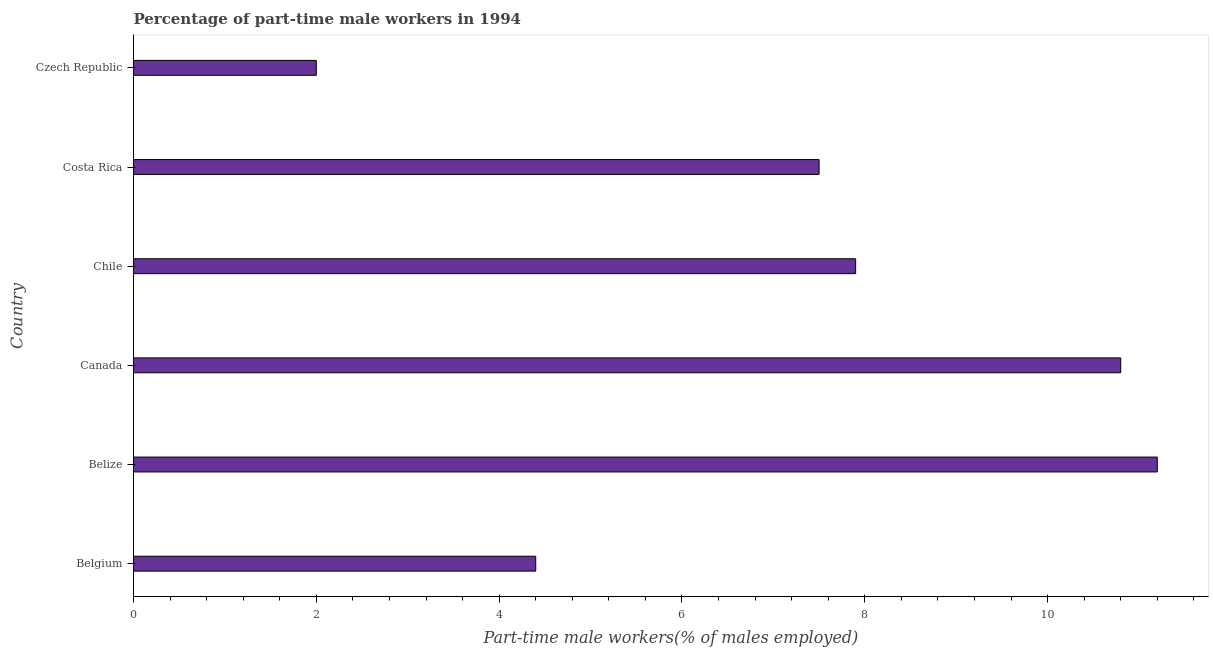Does the graph contain any zero values?
Provide a short and direct response. No. What is the title of the graph?
Keep it short and to the point. Percentage of part-time male workers in 1994. What is the label or title of the X-axis?
Keep it short and to the point. Part-time male workers(% of males employed). What is the percentage of part-time male workers in Canada?
Ensure brevity in your answer.  10.8. Across all countries, what is the maximum percentage of part-time male workers?
Your answer should be very brief. 11.2. In which country was the percentage of part-time male workers maximum?
Provide a succinct answer. Belize. In which country was the percentage of part-time male workers minimum?
Your answer should be very brief. Czech Republic. What is the sum of the percentage of part-time male workers?
Your answer should be very brief. 43.8. What is the difference between the percentage of part-time male workers in Chile and Costa Rica?
Offer a terse response. 0.4. What is the median percentage of part-time male workers?
Keep it short and to the point. 7.7. What is the ratio of the percentage of part-time male workers in Belize to that in Chile?
Your answer should be very brief. 1.42. Is the difference between the percentage of part-time male workers in Belgium and Costa Rica greater than the difference between any two countries?
Provide a succinct answer. No. What is the difference between the highest and the second highest percentage of part-time male workers?
Ensure brevity in your answer.  0.4. In how many countries, is the percentage of part-time male workers greater than the average percentage of part-time male workers taken over all countries?
Your answer should be compact. 4. How many bars are there?
Provide a succinct answer. 6. Are all the bars in the graph horizontal?
Offer a terse response. Yes. How many countries are there in the graph?
Offer a terse response. 6. What is the difference between two consecutive major ticks on the X-axis?
Your answer should be compact. 2. What is the Part-time male workers(% of males employed) in Belgium?
Keep it short and to the point. 4.4. What is the Part-time male workers(% of males employed) of Belize?
Offer a terse response. 11.2. What is the Part-time male workers(% of males employed) of Canada?
Your response must be concise. 10.8. What is the Part-time male workers(% of males employed) in Chile?
Provide a short and direct response. 7.9. What is the difference between the Part-time male workers(% of males employed) in Belgium and Belize?
Provide a succinct answer. -6.8. What is the difference between the Part-time male workers(% of males employed) in Belgium and Chile?
Your response must be concise. -3.5. What is the difference between the Part-time male workers(% of males employed) in Belize and Chile?
Your response must be concise. 3.3. What is the difference between the Part-time male workers(% of males employed) in Belize and Czech Republic?
Offer a terse response. 9.2. What is the difference between the Part-time male workers(% of males employed) in Canada and Costa Rica?
Offer a terse response. 3.3. What is the difference between the Part-time male workers(% of males employed) in Chile and Costa Rica?
Your answer should be compact. 0.4. What is the difference between the Part-time male workers(% of males employed) in Chile and Czech Republic?
Make the answer very short. 5.9. What is the difference between the Part-time male workers(% of males employed) in Costa Rica and Czech Republic?
Provide a short and direct response. 5.5. What is the ratio of the Part-time male workers(% of males employed) in Belgium to that in Belize?
Offer a very short reply. 0.39. What is the ratio of the Part-time male workers(% of males employed) in Belgium to that in Canada?
Make the answer very short. 0.41. What is the ratio of the Part-time male workers(% of males employed) in Belgium to that in Chile?
Provide a short and direct response. 0.56. What is the ratio of the Part-time male workers(% of males employed) in Belgium to that in Costa Rica?
Give a very brief answer. 0.59. What is the ratio of the Part-time male workers(% of males employed) in Belgium to that in Czech Republic?
Your response must be concise. 2.2. What is the ratio of the Part-time male workers(% of males employed) in Belize to that in Canada?
Your answer should be very brief. 1.04. What is the ratio of the Part-time male workers(% of males employed) in Belize to that in Chile?
Provide a short and direct response. 1.42. What is the ratio of the Part-time male workers(% of males employed) in Belize to that in Costa Rica?
Keep it short and to the point. 1.49. What is the ratio of the Part-time male workers(% of males employed) in Canada to that in Chile?
Offer a very short reply. 1.37. What is the ratio of the Part-time male workers(% of males employed) in Canada to that in Costa Rica?
Give a very brief answer. 1.44. What is the ratio of the Part-time male workers(% of males employed) in Chile to that in Costa Rica?
Ensure brevity in your answer.  1.05. What is the ratio of the Part-time male workers(% of males employed) in Chile to that in Czech Republic?
Give a very brief answer. 3.95. What is the ratio of the Part-time male workers(% of males employed) in Costa Rica to that in Czech Republic?
Offer a terse response. 3.75. 